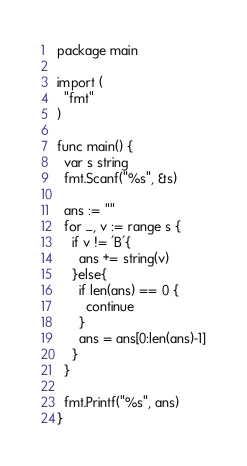<code> <loc_0><loc_0><loc_500><loc_500><_Go_>package main

import (
  "fmt"
)

func main() {
  var s string
  fmt.Scanf("%s", &s)
  
  ans := ""
  for _, v := range s {
    if v != 'B'{
      ans += string(v)
    }else{
      if len(ans) == 0 {
        continue
      }
      ans = ans[0:len(ans)-1]
    }
  }
  
  fmt.Printf("%s", ans)
}</code> 